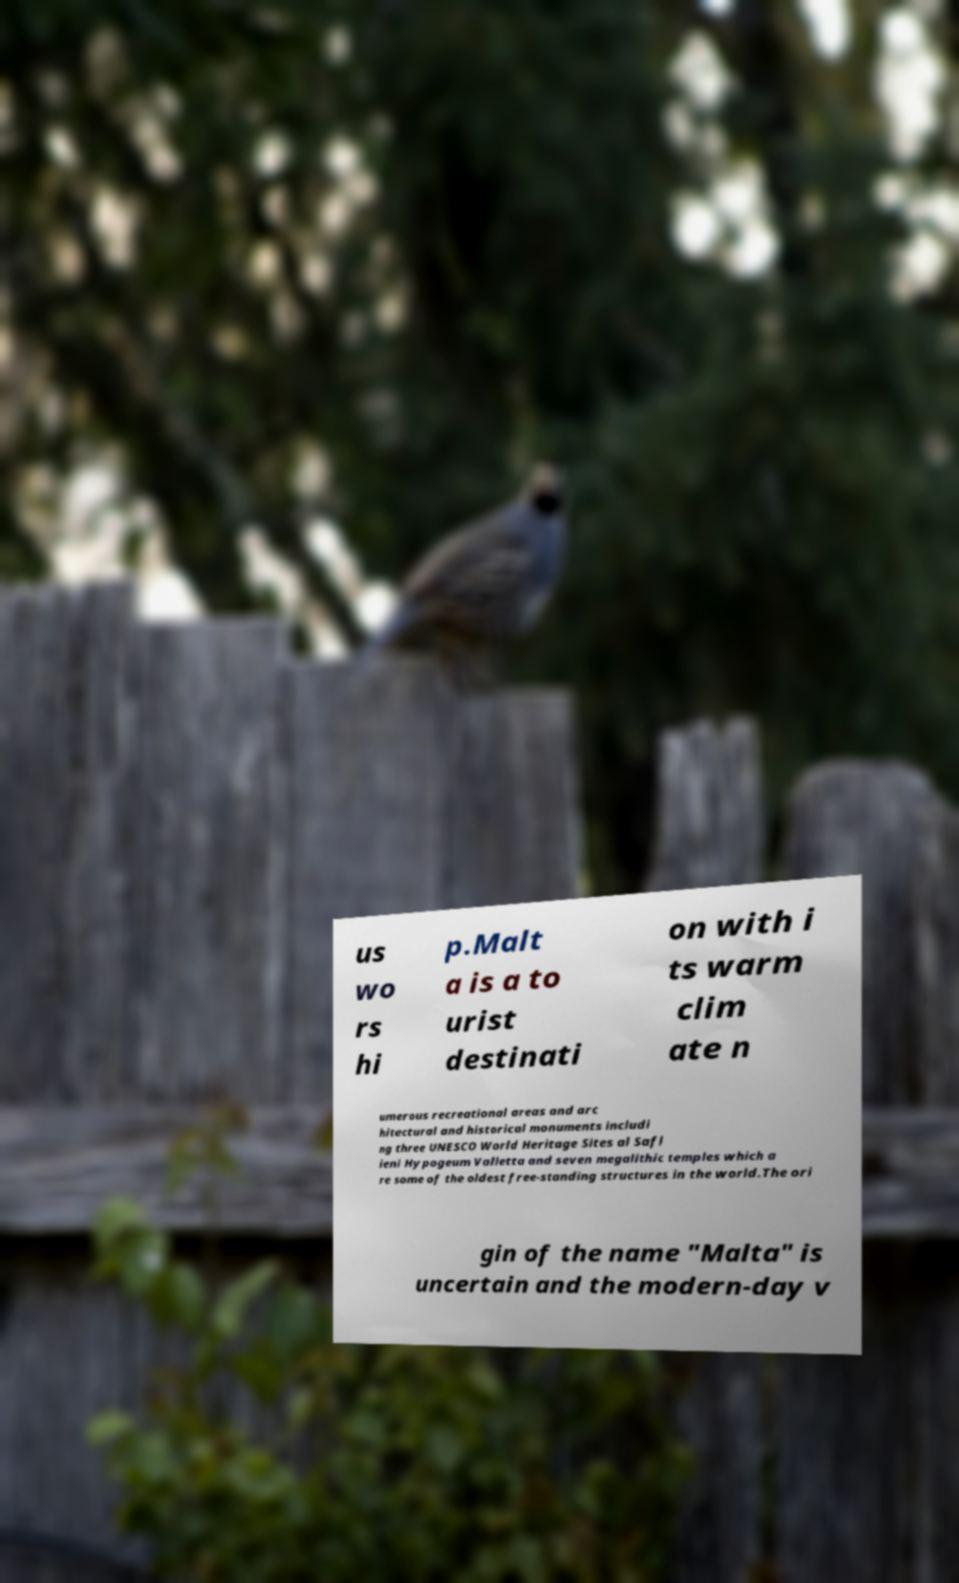What messages or text are displayed in this image? I need them in a readable, typed format. us wo rs hi p.Malt a is a to urist destinati on with i ts warm clim ate n umerous recreational areas and arc hitectural and historical monuments includi ng three UNESCO World Heritage Sites al Safl ieni Hypogeum Valletta and seven megalithic temples which a re some of the oldest free-standing structures in the world.The ori gin of the name "Malta" is uncertain and the modern-day v 